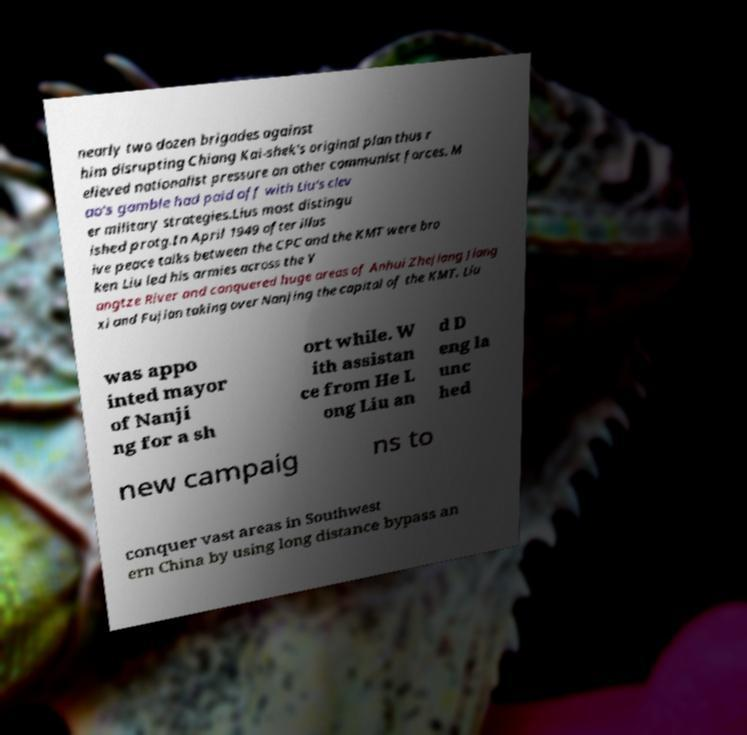For documentation purposes, I need the text within this image transcribed. Could you provide that? nearly two dozen brigades against him disrupting Chiang Kai-shek's original plan thus r elieved nationalist pressure on other communist forces. M ao's gamble had paid off with Liu's clev er military strategies.Lius most distingu ished protg.In April 1949 after illus ive peace talks between the CPC and the KMT were bro ken Liu led his armies across the Y angtze River and conquered huge areas of Anhui Zhejiang Jiang xi and Fujian taking over Nanjing the capital of the KMT. Liu was appo inted mayor of Nanji ng for a sh ort while. W ith assistan ce from He L ong Liu an d D eng la unc hed new campaig ns to conquer vast areas in Southwest ern China by using long distance bypass an 